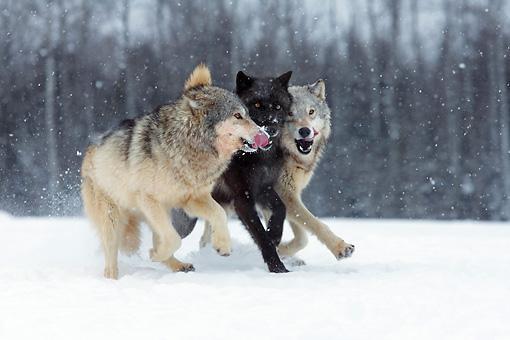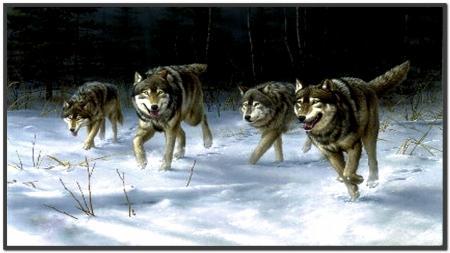The first image is the image on the left, the second image is the image on the right. For the images shown, is this caption "All images show wolves on snow, and the right image contains more wolves than the left image." true? Answer yes or no. Yes. The first image is the image on the left, the second image is the image on the right. For the images displayed, is the sentence "There are seven wolves in total." factually correct? Answer yes or no. Yes. 